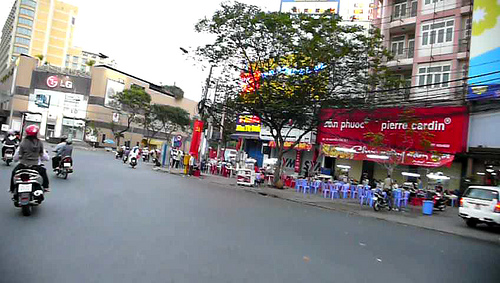Does the sky look gray? Yes, the sky appears gray in the image, suggesting overcast weather. 